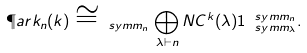Convert formula to latex. <formula><loc_0><loc_0><loc_500><loc_500>\P a r k _ { n } ( k ) \cong _ { \ s y m m _ { n } } \bigoplus _ { \lambda \vdash n } N C ^ { k } ( \lambda ) { 1 } _ { \ s y m m _ { \lambda } } ^ { \ s y m m _ { n } } .</formula> 